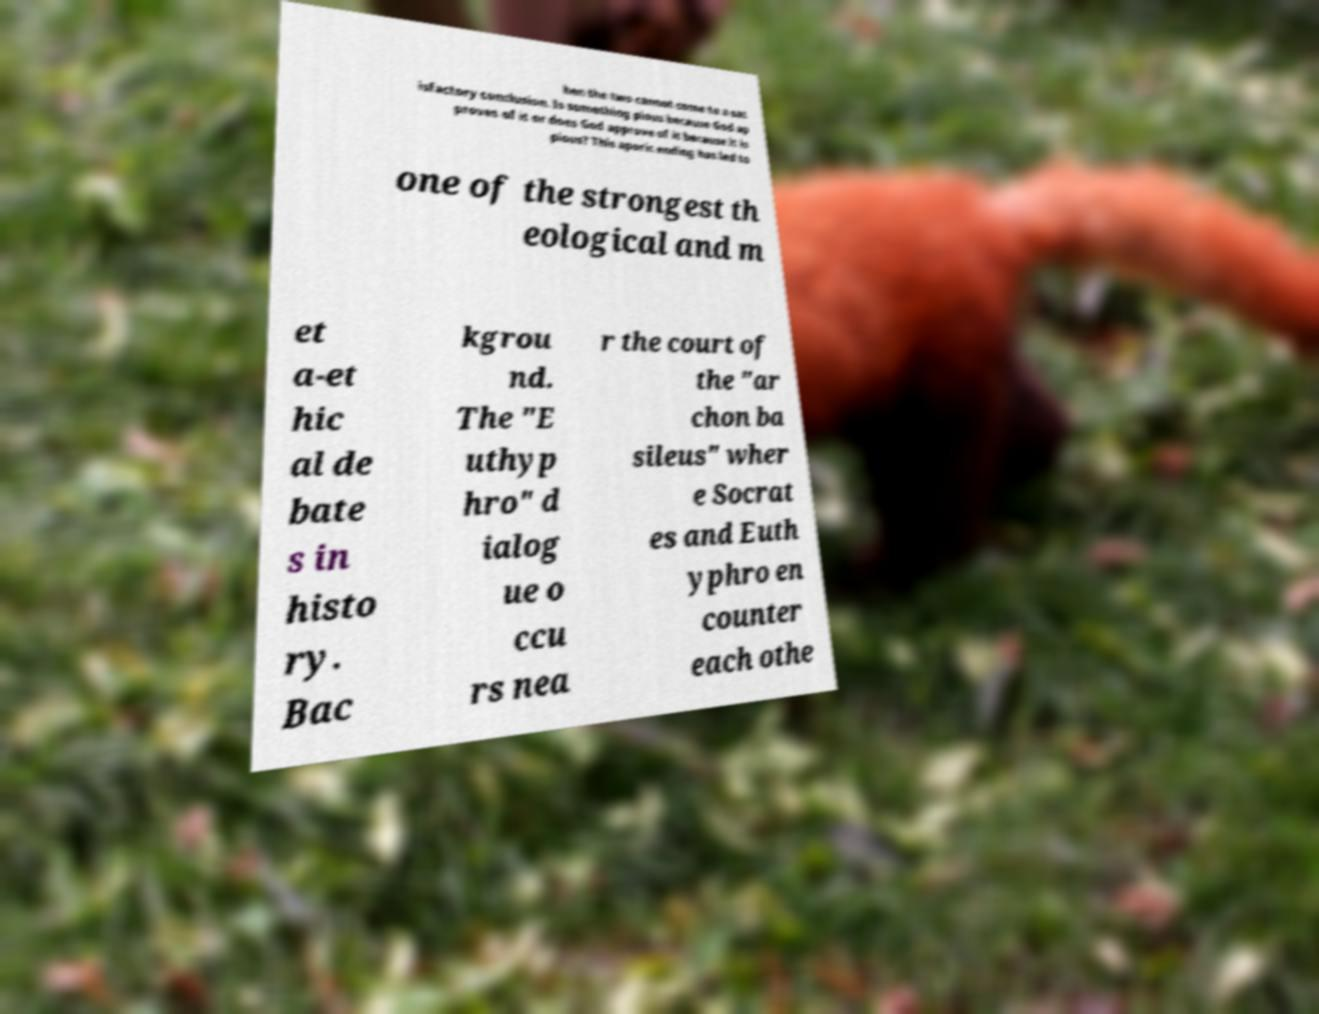Please identify and transcribe the text found in this image. hen the two cannot come to a sat isfactory conclusion. Is something pious because God ap proves of it or does God approve of it because it is pious? This aporic ending has led to one of the strongest th eological and m et a-et hic al de bate s in histo ry. Bac kgrou nd. The "E uthyp hro" d ialog ue o ccu rs nea r the court of the "ar chon ba sileus" wher e Socrat es and Euth yphro en counter each othe 